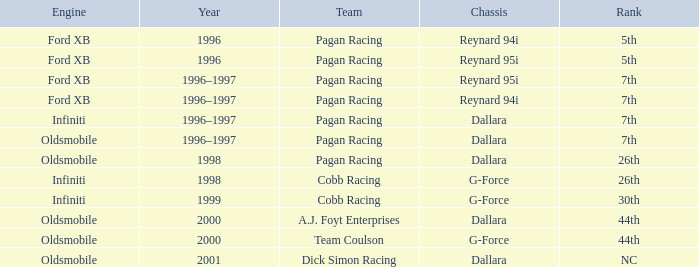Which engine finished 7th with the reynard 95i chassis? Ford XB. 